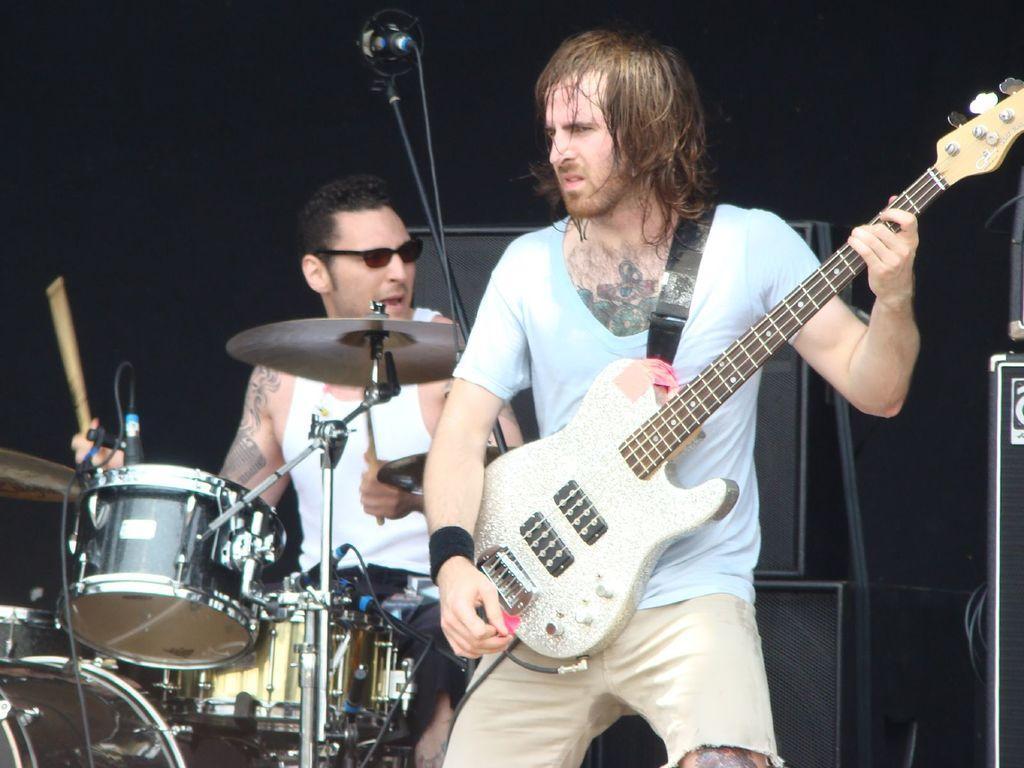Can you describe this image briefly? In this image we can see a person wearing blue color T-shirt playing guitar and in the background of the image there is a person wearing white color dress beating drums there is microphone and some sound boxes. 